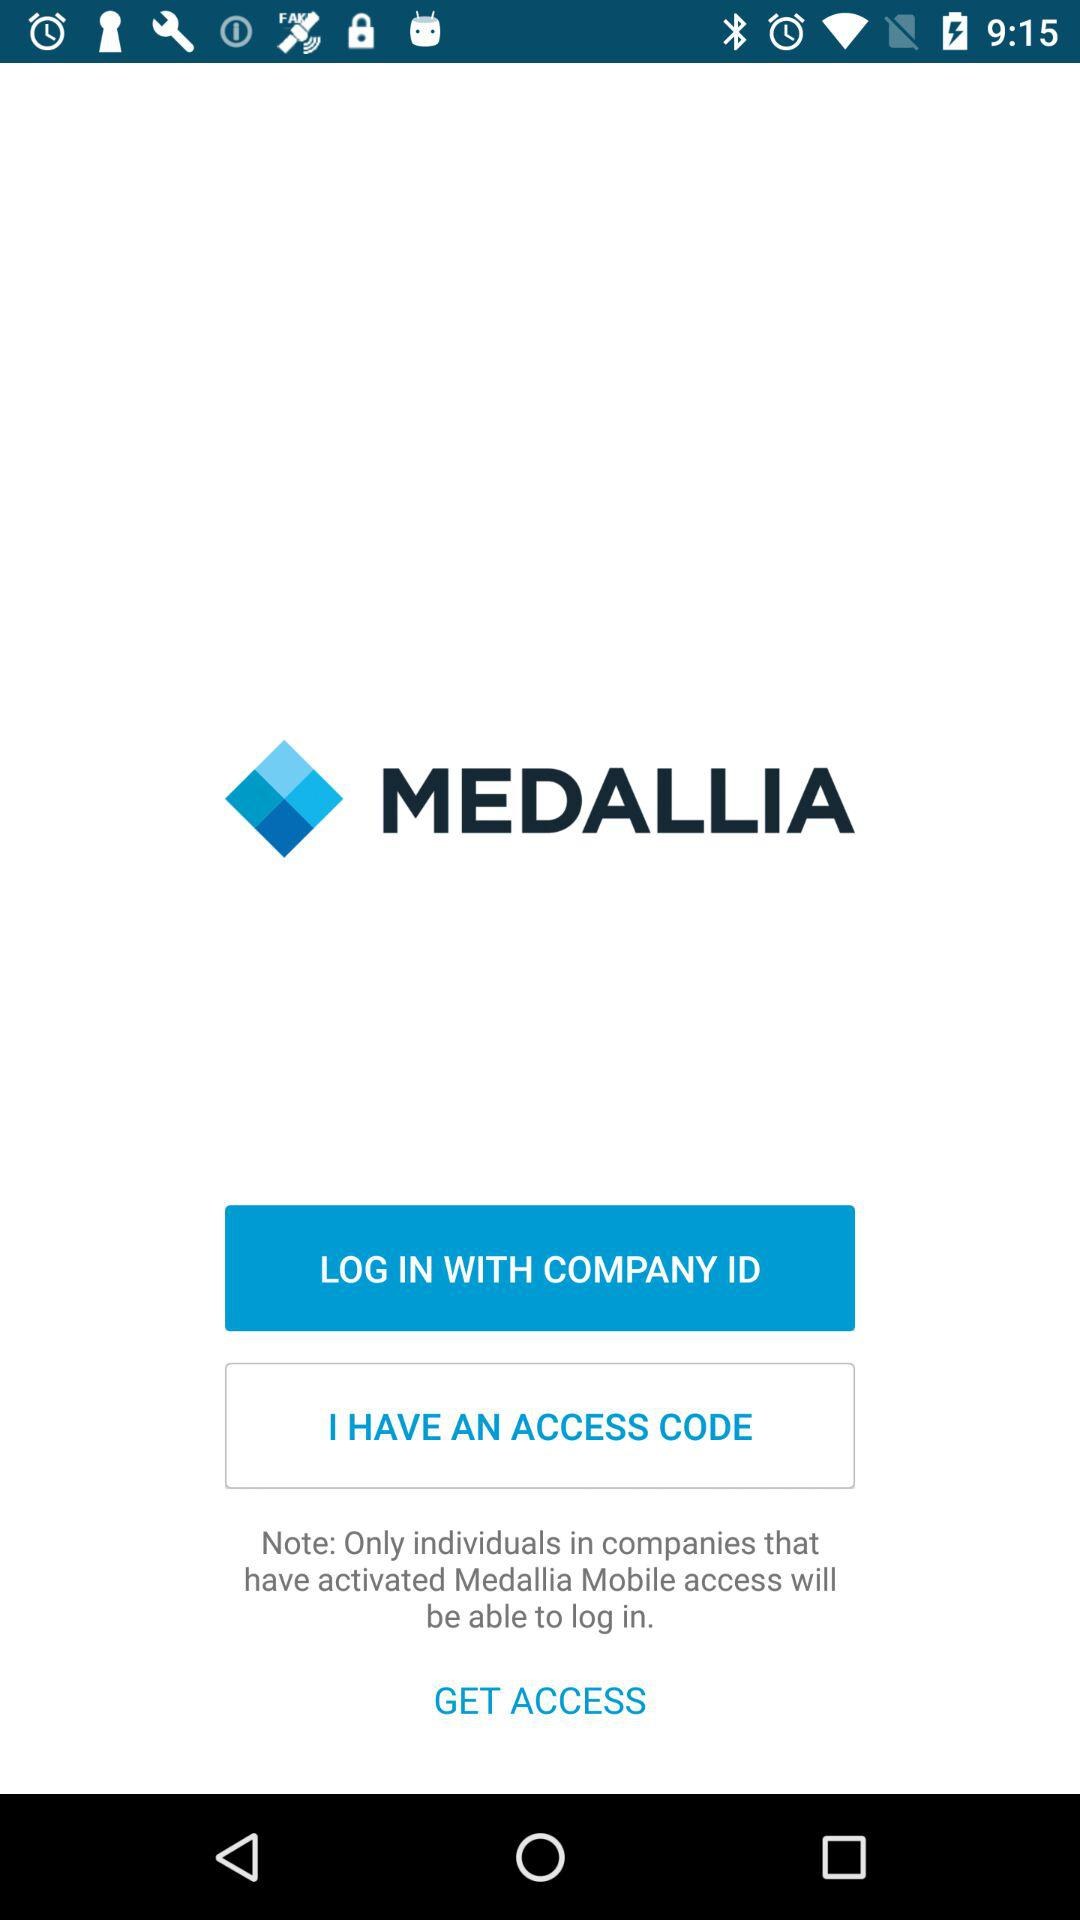What is the company name? The company name is MEDALLIA. 